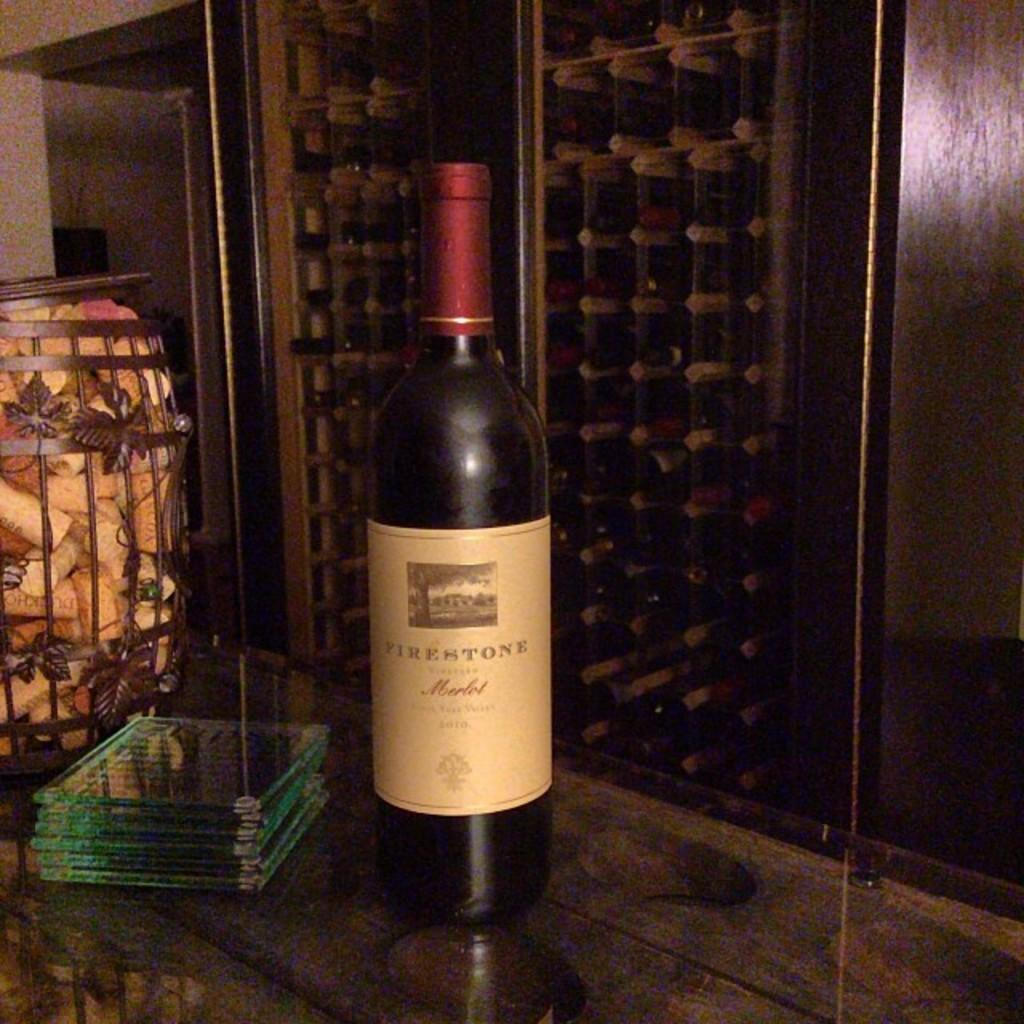Provide a one-sentence caption for the provided image. A bottle of Firestone wine showcased with coasters in a wine cellar in a restaurant. 